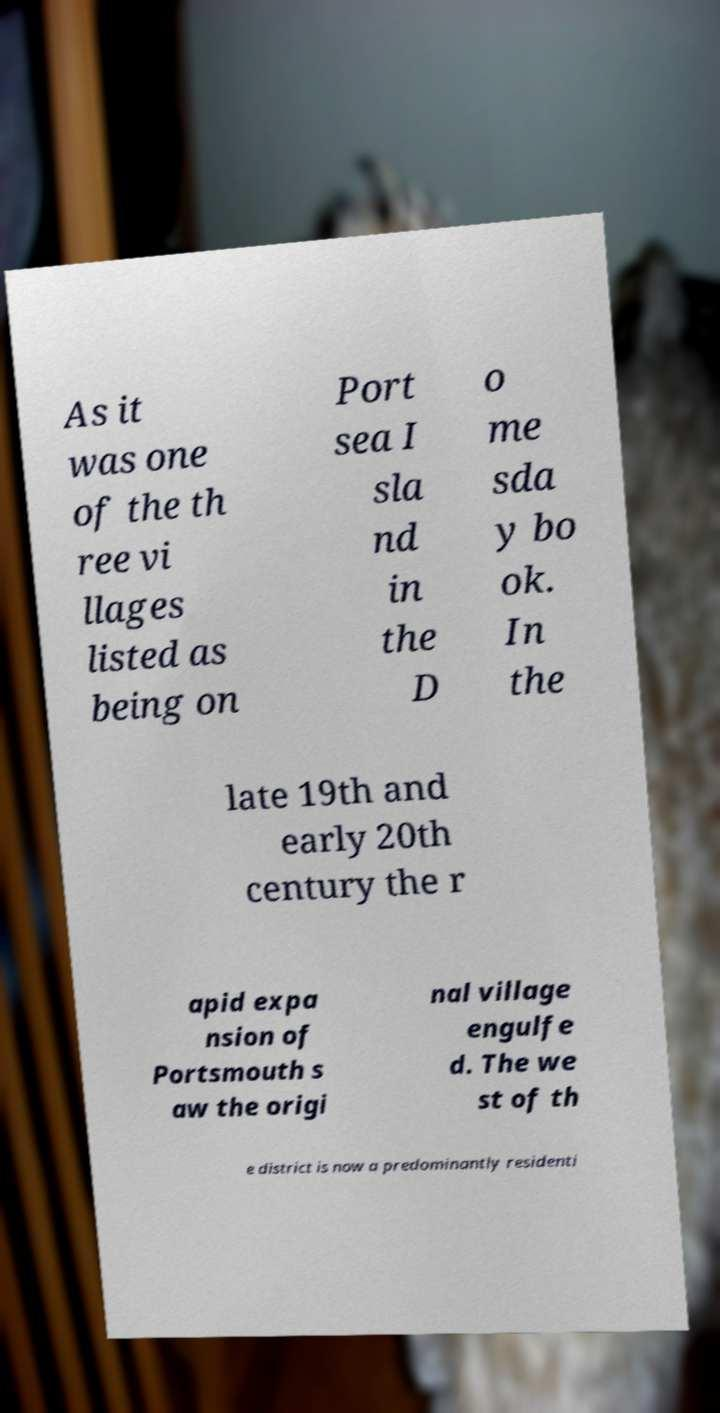What messages or text are displayed in this image? I need them in a readable, typed format. As it was one of the th ree vi llages listed as being on Port sea I sla nd in the D o me sda y bo ok. In the late 19th and early 20th century the r apid expa nsion of Portsmouth s aw the origi nal village engulfe d. The we st of th e district is now a predominantly residenti 